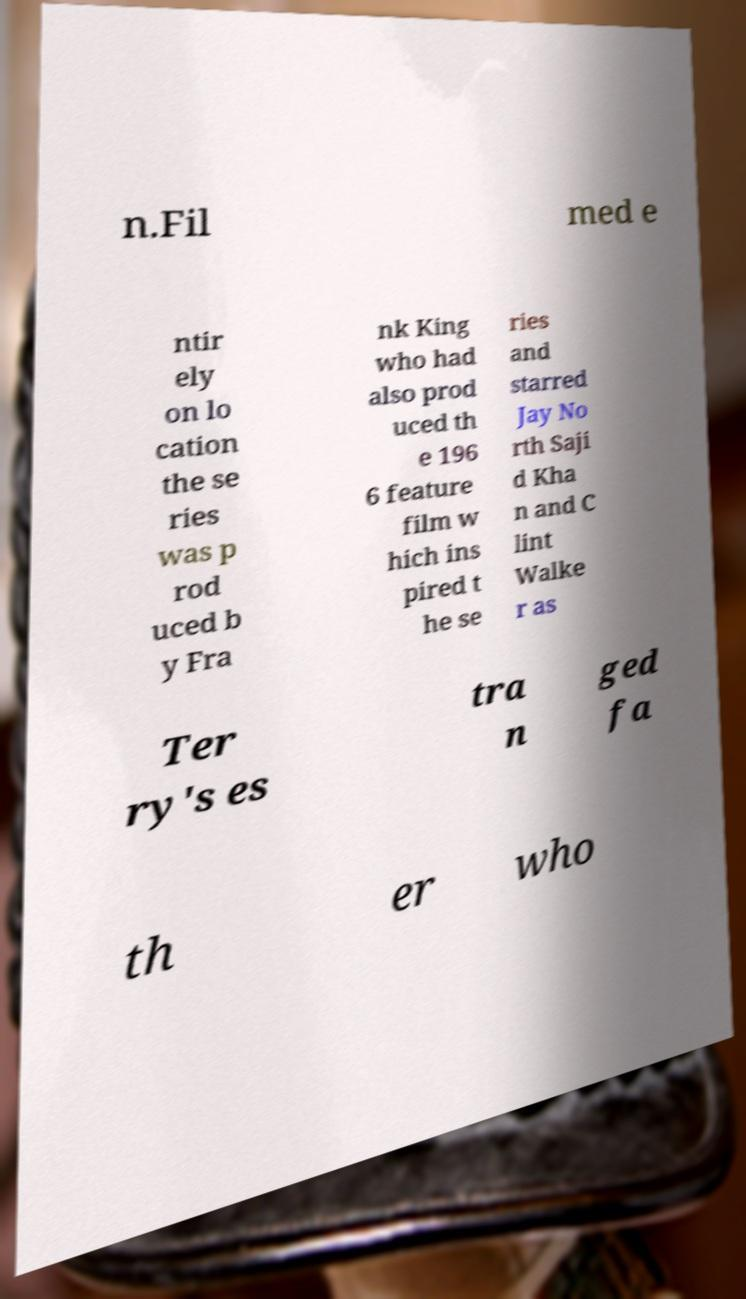There's text embedded in this image that I need extracted. Can you transcribe it verbatim? n.Fil med e ntir ely on lo cation the se ries was p rod uced b y Fra nk King who had also prod uced th e 196 6 feature film w hich ins pired t he se ries and starred Jay No rth Saji d Kha n and C lint Walke r as Ter ry's es tra n ged fa th er who 